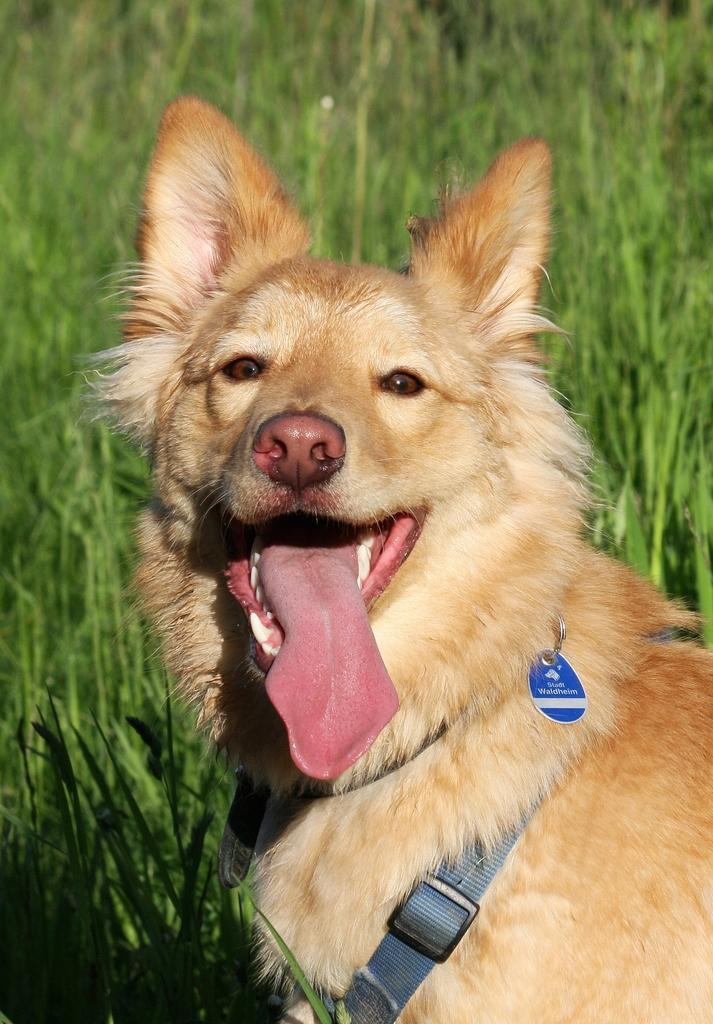What animal is in the front of the image? There is a dog in the front of the image. What type of vegetation can be seen in the background of the image? There is grass visible in the background of the image. What object has a strap in the image? The strap is present in the image, but it is not clear what object it belongs to. What type of bubble is floating near the dog in the image? There is no bubble present in the image; it only features a dog and grass in the background. 